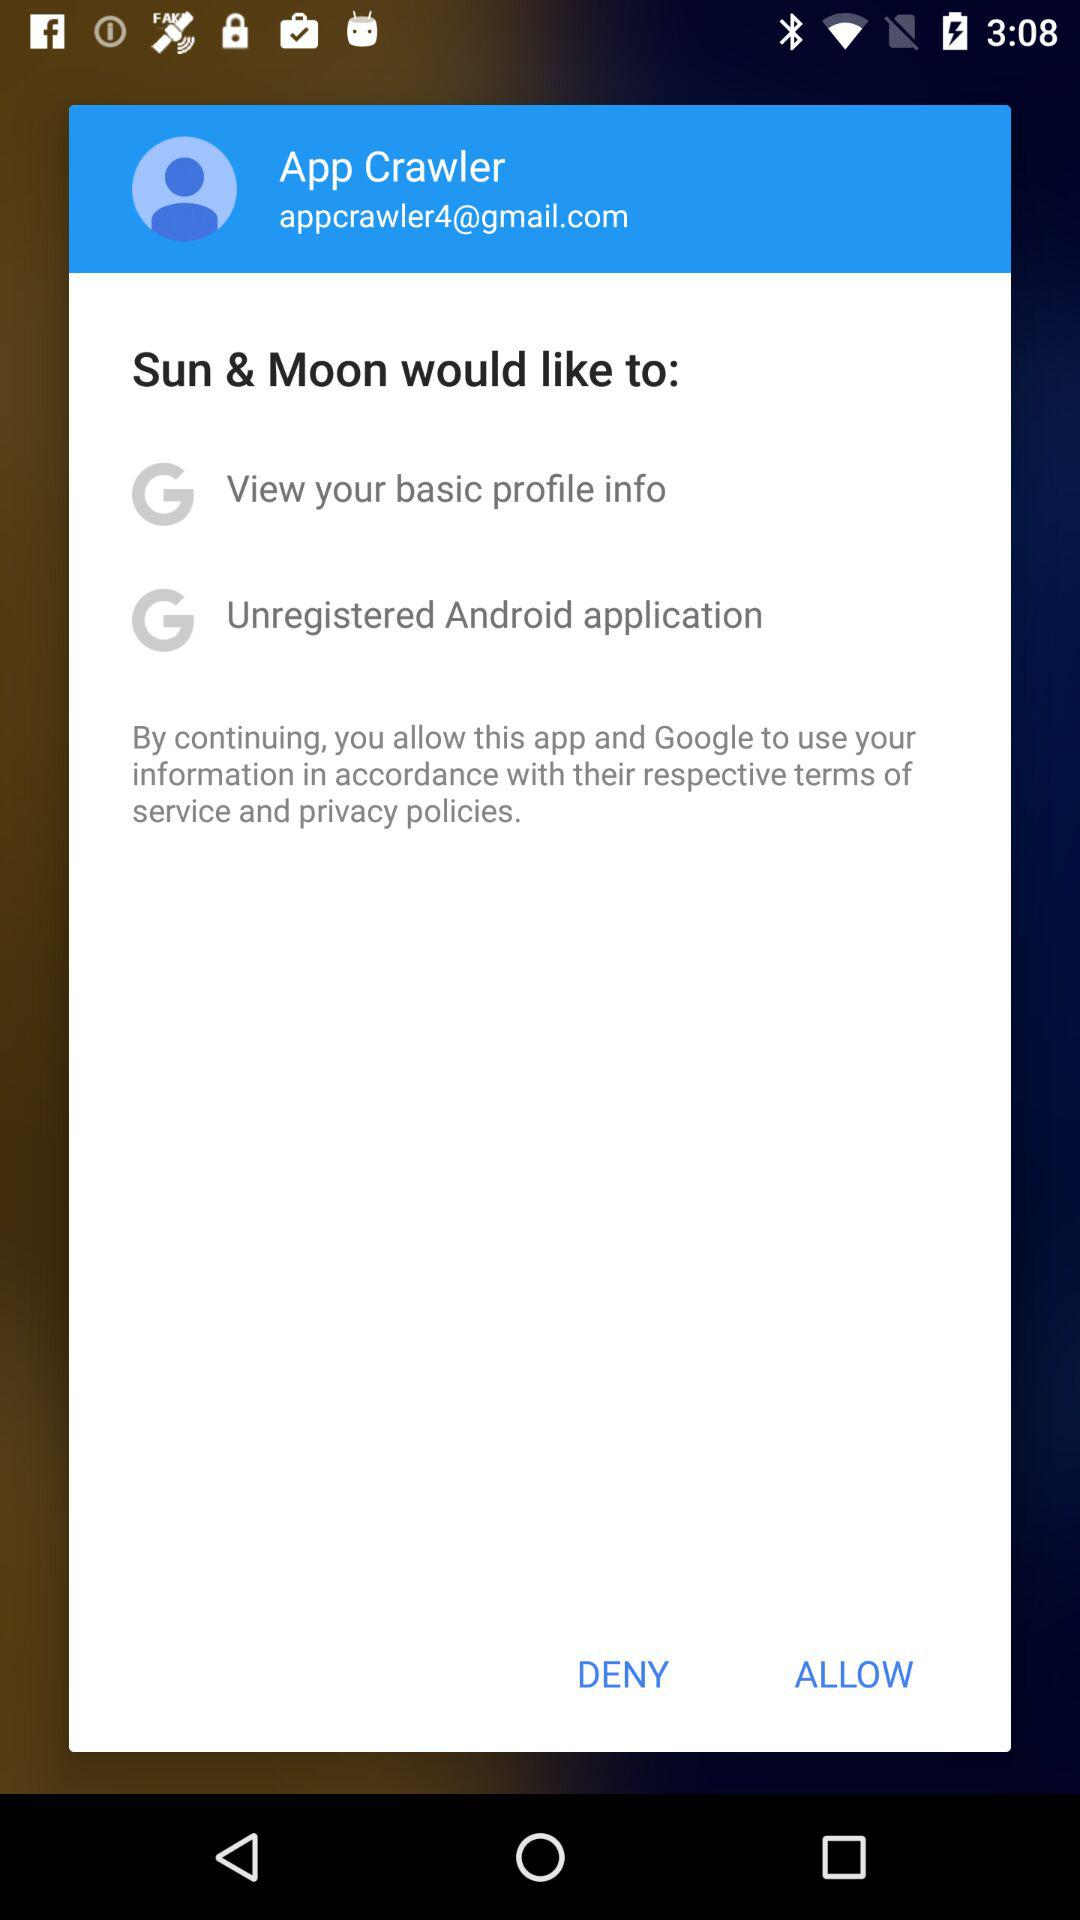What is the user's age?
When the provided information is insufficient, respond with <no answer>. <no answer> 